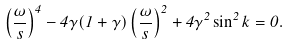<formula> <loc_0><loc_0><loc_500><loc_500>\left ( \frac { \omega } { s } \right ) ^ { 4 } - 4 \gamma ( 1 + \gamma ) \left ( \frac { \omega } { s } \right ) ^ { 2 } + 4 \gamma ^ { 2 } \sin ^ { 2 } k = 0 .</formula> 